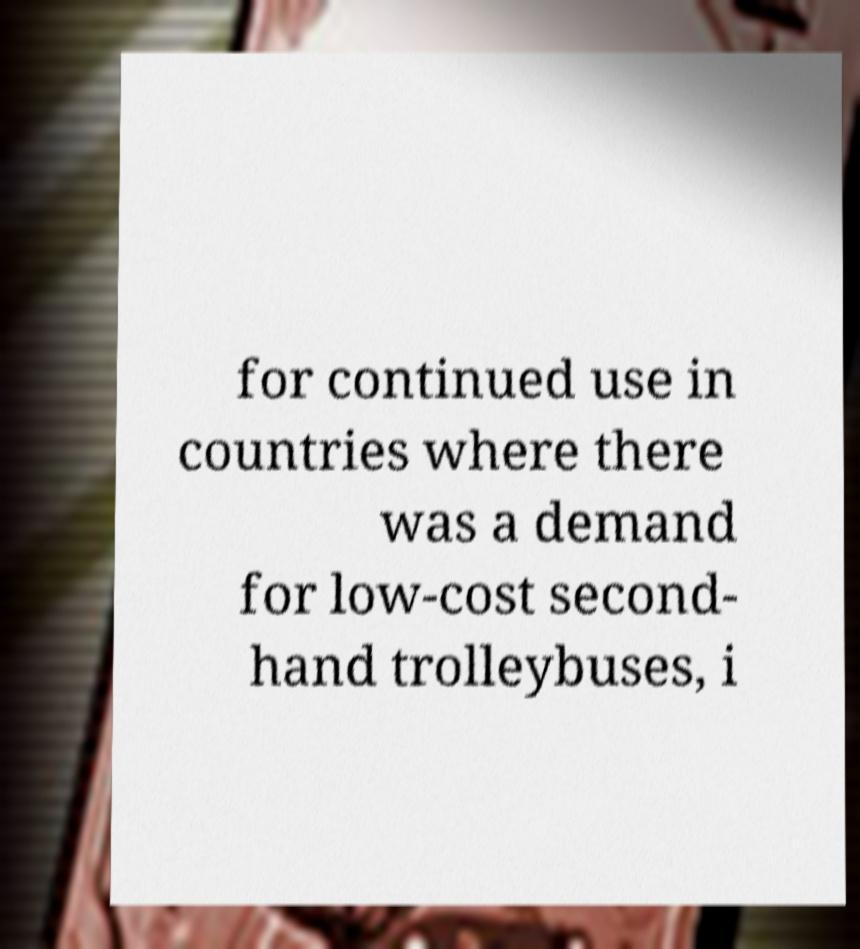I need the written content from this picture converted into text. Can you do that? for continued use in countries where there was a demand for low-cost second- hand trolleybuses, i 